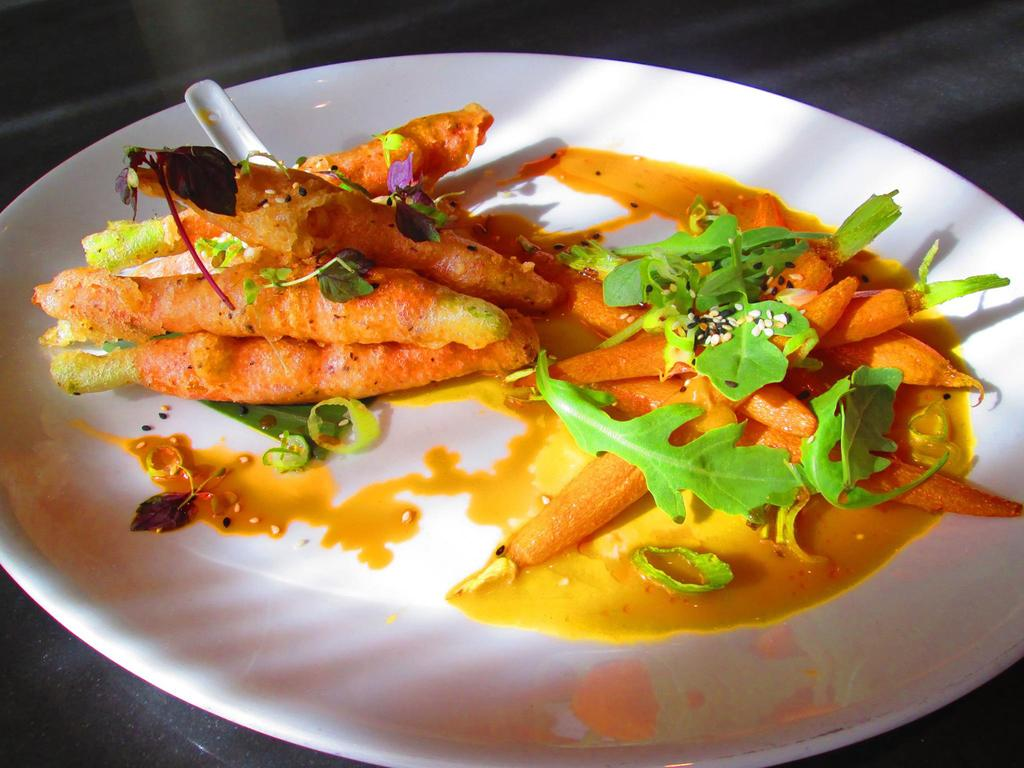What type of food can be seen in the image? The food in the image has brown, cream, and green colors. How is the food arranged in the image? The food is in a plate. What color is the plate? The plate is white. What type of advertisement can be seen in the image? There is no advertisement present in the image; it features food in a plate. What type of locket is visible in the image? There is no locket present in the image. 